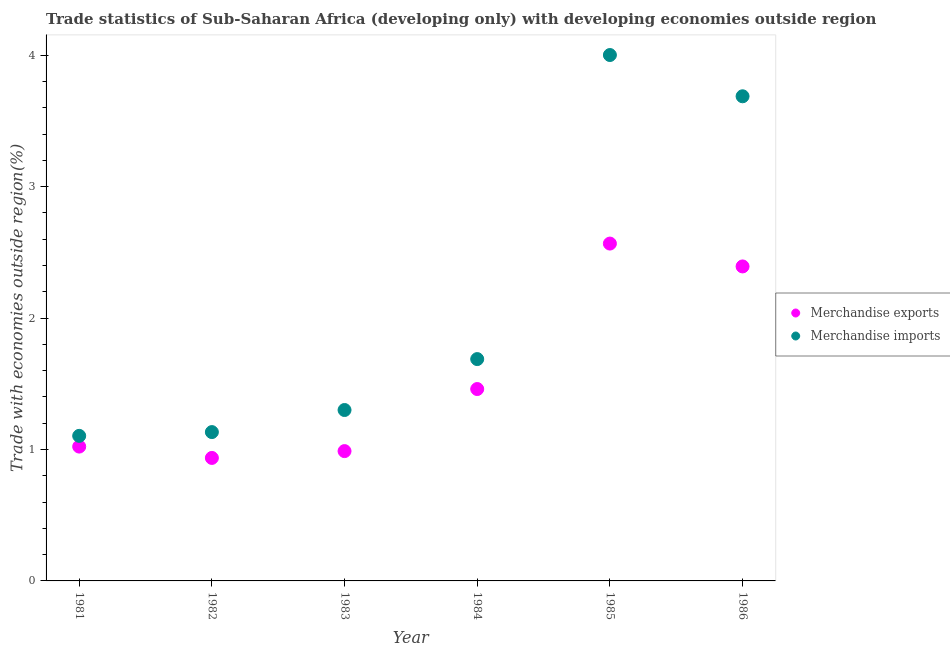What is the merchandise exports in 1986?
Offer a very short reply. 2.39. Across all years, what is the maximum merchandise exports?
Provide a short and direct response. 2.57. Across all years, what is the minimum merchandise imports?
Offer a very short reply. 1.1. In which year was the merchandise imports maximum?
Make the answer very short. 1985. In which year was the merchandise exports minimum?
Offer a very short reply. 1982. What is the total merchandise exports in the graph?
Your response must be concise. 9.37. What is the difference between the merchandise exports in 1981 and that in 1985?
Your answer should be very brief. -1.54. What is the difference between the merchandise exports in 1981 and the merchandise imports in 1984?
Your answer should be very brief. -0.67. What is the average merchandise exports per year?
Ensure brevity in your answer.  1.56. In the year 1984, what is the difference between the merchandise imports and merchandise exports?
Give a very brief answer. 0.23. In how many years, is the merchandise exports greater than 0.4 %?
Make the answer very short. 6. What is the ratio of the merchandise imports in 1981 to that in 1983?
Offer a very short reply. 0.85. Is the difference between the merchandise exports in 1982 and 1986 greater than the difference between the merchandise imports in 1982 and 1986?
Ensure brevity in your answer.  Yes. What is the difference between the highest and the second highest merchandise imports?
Give a very brief answer. 0.31. What is the difference between the highest and the lowest merchandise exports?
Provide a short and direct response. 1.63. In how many years, is the merchandise exports greater than the average merchandise exports taken over all years?
Make the answer very short. 2. Is the merchandise imports strictly greater than the merchandise exports over the years?
Provide a short and direct response. Yes. Is the merchandise imports strictly less than the merchandise exports over the years?
Your response must be concise. No. What is the difference between two consecutive major ticks on the Y-axis?
Offer a very short reply. 1. How many legend labels are there?
Your answer should be compact. 2. How are the legend labels stacked?
Your answer should be very brief. Vertical. What is the title of the graph?
Give a very brief answer. Trade statistics of Sub-Saharan Africa (developing only) with developing economies outside region. What is the label or title of the Y-axis?
Your answer should be very brief. Trade with economies outside region(%). What is the Trade with economies outside region(%) of Merchandise exports in 1981?
Provide a short and direct response. 1.02. What is the Trade with economies outside region(%) in Merchandise imports in 1981?
Your answer should be compact. 1.1. What is the Trade with economies outside region(%) of Merchandise exports in 1982?
Offer a very short reply. 0.94. What is the Trade with economies outside region(%) of Merchandise imports in 1982?
Offer a terse response. 1.13. What is the Trade with economies outside region(%) in Merchandise exports in 1983?
Offer a terse response. 0.99. What is the Trade with economies outside region(%) of Merchandise imports in 1983?
Provide a succinct answer. 1.3. What is the Trade with economies outside region(%) in Merchandise exports in 1984?
Give a very brief answer. 1.46. What is the Trade with economies outside region(%) in Merchandise imports in 1984?
Your response must be concise. 1.69. What is the Trade with economies outside region(%) in Merchandise exports in 1985?
Offer a very short reply. 2.57. What is the Trade with economies outside region(%) of Merchandise imports in 1985?
Your answer should be compact. 4. What is the Trade with economies outside region(%) of Merchandise exports in 1986?
Make the answer very short. 2.39. What is the Trade with economies outside region(%) of Merchandise imports in 1986?
Make the answer very short. 3.69. Across all years, what is the maximum Trade with economies outside region(%) in Merchandise exports?
Provide a short and direct response. 2.57. Across all years, what is the maximum Trade with economies outside region(%) in Merchandise imports?
Your response must be concise. 4. Across all years, what is the minimum Trade with economies outside region(%) of Merchandise exports?
Provide a short and direct response. 0.94. Across all years, what is the minimum Trade with economies outside region(%) in Merchandise imports?
Your response must be concise. 1.1. What is the total Trade with economies outside region(%) in Merchandise exports in the graph?
Make the answer very short. 9.37. What is the total Trade with economies outside region(%) of Merchandise imports in the graph?
Keep it short and to the point. 12.92. What is the difference between the Trade with economies outside region(%) in Merchandise exports in 1981 and that in 1982?
Provide a short and direct response. 0.09. What is the difference between the Trade with economies outside region(%) in Merchandise imports in 1981 and that in 1982?
Your answer should be compact. -0.03. What is the difference between the Trade with economies outside region(%) in Merchandise exports in 1981 and that in 1983?
Offer a terse response. 0.03. What is the difference between the Trade with economies outside region(%) in Merchandise imports in 1981 and that in 1983?
Ensure brevity in your answer.  -0.2. What is the difference between the Trade with economies outside region(%) of Merchandise exports in 1981 and that in 1984?
Give a very brief answer. -0.44. What is the difference between the Trade with economies outside region(%) in Merchandise imports in 1981 and that in 1984?
Offer a very short reply. -0.58. What is the difference between the Trade with economies outside region(%) of Merchandise exports in 1981 and that in 1985?
Make the answer very short. -1.54. What is the difference between the Trade with economies outside region(%) of Merchandise imports in 1981 and that in 1985?
Make the answer very short. -2.9. What is the difference between the Trade with economies outside region(%) in Merchandise exports in 1981 and that in 1986?
Provide a short and direct response. -1.37. What is the difference between the Trade with economies outside region(%) of Merchandise imports in 1981 and that in 1986?
Your response must be concise. -2.58. What is the difference between the Trade with economies outside region(%) of Merchandise exports in 1982 and that in 1983?
Keep it short and to the point. -0.05. What is the difference between the Trade with economies outside region(%) of Merchandise imports in 1982 and that in 1983?
Ensure brevity in your answer.  -0.17. What is the difference between the Trade with economies outside region(%) of Merchandise exports in 1982 and that in 1984?
Provide a short and direct response. -0.52. What is the difference between the Trade with economies outside region(%) in Merchandise imports in 1982 and that in 1984?
Provide a short and direct response. -0.56. What is the difference between the Trade with economies outside region(%) of Merchandise exports in 1982 and that in 1985?
Offer a very short reply. -1.63. What is the difference between the Trade with economies outside region(%) of Merchandise imports in 1982 and that in 1985?
Offer a very short reply. -2.87. What is the difference between the Trade with economies outside region(%) in Merchandise exports in 1982 and that in 1986?
Make the answer very short. -1.46. What is the difference between the Trade with economies outside region(%) in Merchandise imports in 1982 and that in 1986?
Provide a short and direct response. -2.56. What is the difference between the Trade with economies outside region(%) of Merchandise exports in 1983 and that in 1984?
Keep it short and to the point. -0.47. What is the difference between the Trade with economies outside region(%) in Merchandise imports in 1983 and that in 1984?
Your answer should be compact. -0.39. What is the difference between the Trade with economies outside region(%) of Merchandise exports in 1983 and that in 1985?
Give a very brief answer. -1.58. What is the difference between the Trade with economies outside region(%) of Merchandise imports in 1983 and that in 1985?
Give a very brief answer. -2.7. What is the difference between the Trade with economies outside region(%) in Merchandise exports in 1983 and that in 1986?
Make the answer very short. -1.41. What is the difference between the Trade with economies outside region(%) of Merchandise imports in 1983 and that in 1986?
Keep it short and to the point. -2.39. What is the difference between the Trade with economies outside region(%) in Merchandise exports in 1984 and that in 1985?
Give a very brief answer. -1.11. What is the difference between the Trade with economies outside region(%) of Merchandise imports in 1984 and that in 1985?
Your answer should be compact. -2.31. What is the difference between the Trade with economies outside region(%) of Merchandise exports in 1984 and that in 1986?
Make the answer very short. -0.93. What is the difference between the Trade with economies outside region(%) of Merchandise imports in 1984 and that in 1986?
Provide a short and direct response. -2. What is the difference between the Trade with economies outside region(%) of Merchandise exports in 1985 and that in 1986?
Your answer should be compact. 0.17. What is the difference between the Trade with economies outside region(%) in Merchandise imports in 1985 and that in 1986?
Give a very brief answer. 0.31. What is the difference between the Trade with economies outside region(%) in Merchandise exports in 1981 and the Trade with economies outside region(%) in Merchandise imports in 1982?
Provide a short and direct response. -0.11. What is the difference between the Trade with economies outside region(%) in Merchandise exports in 1981 and the Trade with economies outside region(%) in Merchandise imports in 1983?
Your answer should be very brief. -0.28. What is the difference between the Trade with economies outside region(%) of Merchandise exports in 1981 and the Trade with economies outside region(%) of Merchandise imports in 1984?
Provide a short and direct response. -0.67. What is the difference between the Trade with economies outside region(%) of Merchandise exports in 1981 and the Trade with economies outside region(%) of Merchandise imports in 1985?
Keep it short and to the point. -2.98. What is the difference between the Trade with economies outside region(%) in Merchandise exports in 1981 and the Trade with economies outside region(%) in Merchandise imports in 1986?
Keep it short and to the point. -2.67. What is the difference between the Trade with economies outside region(%) of Merchandise exports in 1982 and the Trade with economies outside region(%) of Merchandise imports in 1983?
Offer a terse response. -0.36. What is the difference between the Trade with economies outside region(%) of Merchandise exports in 1982 and the Trade with economies outside region(%) of Merchandise imports in 1984?
Your answer should be compact. -0.75. What is the difference between the Trade with economies outside region(%) in Merchandise exports in 1982 and the Trade with economies outside region(%) in Merchandise imports in 1985?
Your answer should be very brief. -3.07. What is the difference between the Trade with economies outside region(%) in Merchandise exports in 1982 and the Trade with economies outside region(%) in Merchandise imports in 1986?
Your response must be concise. -2.75. What is the difference between the Trade with economies outside region(%) of Merchandise exports in 1983 and the Trade with economies outside region(%) of Merchandise imports in 1984?
Your response must be concise. -0.7. What is the difference between the Trade with economies outside region(%) in Merchandise exports in 1983 and the Trade with economies outside region(%) in Merchandise imports in 1985?
Keep it short and to the point. -3.01. What is the difference between the Trade with economies outside region(%) of Merchandise exports in 1983 and the Trade with economies outside region(%) of Merchandise imports in 1986?
Offer a very short reply. -2.7. What is the difference between the Trade with economies outside region(%) of Merchandise exports in 1984 and the Trade with economies outside region(%) of Merchandise imports in 1985?
Give a very brief answer. -2.54. What is the difference between the Trade with economies outside region(%) of Merchandise exports in 1984 and the Trade with economies outside region(%) of Merchandise imports in 1986?
Ensure brevity in your answer.  -2.23. What is the difference between the Trade with economies outside region(%) in Merchandise exports in 1985 and the Trade with economies outside region(%) in Merchandise imports in 1986?
Your answer should be very brief. -1.12. What is the average Trade with economies outside region(%) of Merchandise exports per year?
Offer a terse response. 1.56. What is the average Trade with economies outside region(%) of Merchandise imports per year?
Keep it short and to the point. 2.15. In the year 1981, what is the difference between the Trade with economies outside region(%) of Merchandise exports and Trade with economies outside region(%) of Merchandise imports?
Provide a short and direct response. -0.08. In the year 1982, what is the difference between the Trade with economies outside region(%) in Merchandise exports and Trade with economies outside region(%) in Merchandise imports?
Provide a short and direct response. -0.2. In the year 1983, what is the difference between the Trade with economies outside region(%) of Merchandise exports and Trade with economies outside region(%) of Merchandise imports?
Provide a succinct answer. -0.31. In the year 1984, what is the difference between the Trade with economies outside region(%) of Merchandise exports and Trade with economies outside region(%) of Merchandise imports?
Provide a succinct answer. -0.23. In the year 1985, what is the difference between the Trade with economies outside region(%) of Merchandise exports and Trade with economies outside region(%) of Merchandise imports?
Your answer should be very brief. -1.44. In the year 1986, what is the difference between the Trade with economies outside region(%) in Merchandise exports and Trade with economies outside region(%) in Merchandise imports?
Give a very brief answer. -1.29. What is the ratio of the Trade with economies outside region(%) of Merchandise exports in 1981 to that in 1982?
Offer a very short reply. 1.09. What is the ratio of the Trade with economies outside region(%) in Merchandise imports in 1981 to that in 1982?
Keep it short and to the point. 0.97. What is the ratio of the Trade with economies outside region(%) in Merchandise exports in 1981 to that in 1983?
Provide a succinct answer. 1.03. What is the ratio of the Trade with economies outside region(%) in Merchandise imports in 1981 to that in 1983?
Your answer should be very brief. 0.85. What is the ratio of the Trade with economies outside region(%) of Merchandise exports in 1981 to that in 1984?
Make the answer very short. 0.7. What is the ratio of the Trade with economies outside region(%) in Merchandise imports in 1981 to that in 1984?
Provide a succinct answer. 0.65. What is the ratio of the Trade with economies outside region(%) in Merchandise exports in 1981 to that in 1985?
Ensure brevity in your answer.  0.4. What is the ratio of the Trade with economies outside region(%) in Merchandise imports in 1981 to that in 1985?
Ensure brevity in your answer.  0.28. What is the ratio of the Trade with economies outside region(%) in Merchandise exports in 1981 to that in 1986?
Offer a terse response. 0.43. What is the ratio of the Trade with economies outside region(%) in Merchandise imports in 1981 to that in 1986?
Your response must be concise. 0.3. What is the ratio of the Trade with economies outside region(%) in Merchandise imports in 1982 to that in 1983?
Your answer should be compact. 0.87. What is the ratio of the Trade with economies outside region(%) in Merchandise exports in 1982 to that in 1984?
Offer a terse response. 0.64. What is the ratio of the Trade with economies outside region(%) of Merchandise imports in 1982 to that in 1984?
Keep it short and to the point. 0.67. What is the ratio of the Trade with economies outside region(%) in Merchandise exports in 1982 to that in 1985?
Offer a very short reply. 0.36. What is the ratio of the Trade with economies outside region(%) in Merchandise imports in 1982 to that in 1985?
Offer a terse response. 0.28. What is the ratio of the Trade with economies outside region(%) of Merchandise exports in 1982 to that in 1986?
Make the answer very short. 0.39. What is the ratio of the Trade with economies outside region(%) of Merchandise imports in 1982 to that in 1986?
Offer a terse response. 0.31. What is the ratio of the Trade with economies outside region(%) of Merchandise exports in 1983 to that in 1984?
Make the answer very short. 0.68. What is the ratio of the Trade with economies outside region(%) in Merchandise imports in 1983 to that in 1984?
Provide a short and direct response. 0.77. What is the ratio of the Trade with economies outside region(%) in Merchandise exports in 1983 to that in 1985?
Give a very brief answer. 0.38. What is the ratio of the Trade with economies outside region(%) in Merchandise imports in 1983 to that in 1985?
Give a very brief answer. 0.33. What is the ratio of the Trade with economies outside region(%) of Merchandise exports in 1983 to that in 1986?
Make the answer very short. 0.41. What is the ratio of the Trade with economies outside region(%) of Merchandise imports in 1983 to that in 1986?
Provide a succinct answer. 0.35. What is the ratio of the Trade with economies outside region(%) in Merchandise exports in 1984 to that in 1985?
Keep it short and to the point. 0.57. What is the ratio of the Trade with economies outside region(%) in Merchandise imports in 1984 to that in 1985?
Ensure brevity in your answer.  0.42. What is the ratio of the Trade with economies outside region(%) in Merchandise exports in 1984 to that in 1986?
Offer a terse response. 0.61. What is the ratio of the Trade with economies outside region(%) of Merchandise imports in 1984 to that in 1986?
Ensure brevity in your answer.  0.46. What is the ratio of the Trade with economies outside region(%) in Merchandise exports in 1985 to that in 1986?
Your answer should be very brief. 1.07. What is the ratio of the Trade with economies outside region(%) in Merchandise imports in 1985 to that in 1986?
Keep it short and to the point. 1.09. What is the difference between the highest and the second highest Trade with economies outside region(%) in Merchandise exports?
Your answer should be very brief. 0.17. What is the difference between the highest and the second highest Trade with economies outside region(%) in Merchandise imports?
Your response must be concise. 0.31. What is the difference between the highest and the lowest Trade with economies outside region(%) in Merchandise exports?
Provide a succinct answer. 1.63. What is the difference between the highest and the lowest Trade with economies outside region(%) of Merchandise imports?
Offer a very short reply. 2.9. 